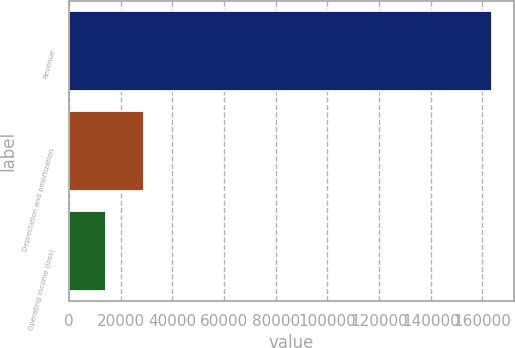Convert chart to OTSL. <chart><loc_0><loc_0><loc_500><loc_500><bar_chart><fcel>Revenue<fcel>Depreciation and amortization<fcel>Operating income (loss)<nl><fcel>163878<fcel>29163.3<fcel>14195<nl></chart> 